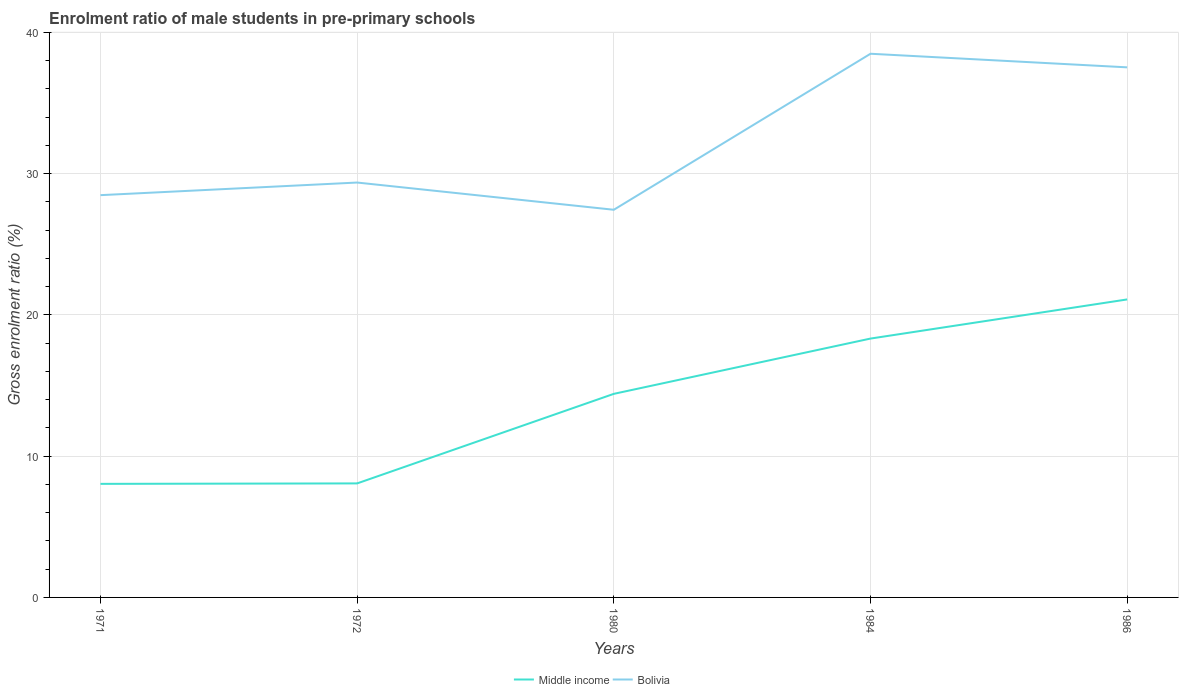Does the line corresponding to Bolivia intersect with the line corresponding to Middle income?
Give a very brief answer. No. Across all years, what is the maximum enrolment ratio of male students in pre-primary schools in Bolivia?
Your answer should be very brief. 27.44. In which year was the enrolment ratio of male students in pre-primary schools in Bolivia maximum?
Ensure brevity in your answer.  1980. What is the total enrolment ratio of male students in pre-primary schools in Bolivia in the graph?
Your response must be concise. -10.01. What is the difference between the highest and the second highest enrolment ratio of male students in pre-primary schools in Middle income?
Offer a terse response. 13.05. What is the difference between the highest and the lowest enrolment ratio of male students in pre-primary schools in Bolivia?
Provide a short and direct response. 2. How many lines are there?
Provide a succinct answer. 2. How many legend labels are there?
Your answer should be compact. 2. How are the legend labels stacked?
Give a very brief answer. Horizontal. What is the title of the graph?
Offer a very short reply. Enrolment ratio of male students in pre-primary schools. What is the label or title of the X-axis?
Offer a very short reply. Years. What is the Gross enrolment ratio (%) of Middle income in 1971?
Make the answer very short. 8.04. What is the Gross enrolment ratio (%) of Bolivia in 1971?
Your answer should be very brief. 28.47. What is the Gross enrolment ratio (%) of Middle income in 1972?
Offer a terse response. 8.07. What is the Gross enrolment ratio (%) of Bolivia in 1972?
Your response must be concise. 29.36. What is the Gross enrolment ratio (%) of Middle income in 1980?
Your answer should be compact. 14.41. What is the Gross enrolment ratio (%) in Bolivia in 1980?
Offer a terse response. 27.44. What is the Gross enrolment ratio (%) in Middle income in 1984?
Provide a succinct answer. 18.32. What is the Gross enrolment ratio (%) in Bolivia in 1984?
Provide a short and direct response. 38.48. What is the Gross enrolment ratio (%) of Middle income in 1986?
Give a very brief answer. 21.09. What is the Gross enrolment ratio (%) of Bolivia in 1986?
Your answer should be compact. 37.52. Across all years, what is the maximum Gross enrolment ratio (%) in Middle income?
Your answer should be compact. 21.09. Across all years, what is the maximum Gross enrolment ratio (%) in Bolivia?
Your answer should be compact. 38.48. Across all years, what is the minimum Gross enrolment ratio (%) of Middle income?
Provide a short and direct response. 8.04. Across all years, what is the minimum Gross enrolment ratio (%) in Bolivia?
Offer a very short reply. 27.44. What is the total Gross enrolment ratio (%) in Middle income in the graph?
Your answer should be compact. 69.93. What is the total Gross enrolment ratio (%) in Bolivia in the graph?
Give a very brief answer. 161.27. What is the difference between the Gross enrolment ratio (%) in Middle income in 1971 and that in 1972?
Ensure brevity in your answer.  -0.03. What is the difference between the Gross enrolment ratio (%) in Bolivia in 1971 and that in 1972?
Give a very brief answer. -0.89. What is the difference between the Gross enrolment ratio (%) in Middle income in 1971 and that in 1980?
Make the answer very short. -6.37. What is the difference between the Gross enrolment ratio (%) in Bolivia in 1971 and that in 1980?
Your response must be concise. 1.03. What is the difference between the Gross enrolment ratio (%) in Middle income in 1971 and that in 1984?
Provide a short and direct response. -10.28. What is the difference between the Gross enrolment ratio (%) in Bolivia in 1971 and that in 1984?
Offer a very short reply. -10.01. What is the difference between the Gross enrolment ratio (%) of Middle income in 1971 and that in 1986?
Your answer should be very brief. -13.05. What is the difference between the Gross enrolment ratio (%) in Bolivia in 1971 and that in 1986?
Give a very brief answer. -9.05. What is the difference between the Gross enrolment ratio (%) of Middle income in 1972 and that in 1980?
Your answer should be compact. -6.34. What is the difference between the Gross enrolment ratio (%) of Bolivia in 1972 and that in 1980?
Provide a short and direct response. 1.93. What is the difference between the Gross enrolment ratio (%) in Middle income in 1972 and that in 1984?
Provide a succinct answer. -10.25. What is the difference between the Gross enrolment ratio (%) of Bolivia in 1972 and that in 1984?
Your answer should be compact. -9.11. What is the difference between the Gross enrolment ratio (%) in Middle income in 1972 and that in 1986?
Provide a succinct answer. -13.02. What is the difference between the Gross enrolment ratio (%) in Bolivia in 1972 and that in 1986?
Make the answer very short. -8.15. What is the difference between the Gross enrolment ratio (%) in Middle income in 1980 and that in 1984?
Offer a very short reply. -3.91. What is the difference between the Gross enrolment ratio (%) of Bolivia in 1980 and that in 1984?
Offer a very short reply. -11.04. What is the difference between the Gross enrolment ratio (%) in Middle income in 1980 and that in 1986?
Give a very brief answer. -6.68. What is the difference between the Gross enrolment ratio (%) in Bolivia in 1980 and that in 1986?
Make the answer very short. -10.08. What is the difference between the Gross enrolment ratio (%) in Middle income in 1984 and that in 1986?
Ensure brevity in your answer.  -2.77. What is the difference between the Gross enrolment ratio (%) in Bolivia in 1984 and that in 1986?
Offer a very short reply. 0.96. What is the difference between the Gross enrolment ratio (%) of Middle income in 1971 and the Gross enrolment ratio (%) of Bolivia in 1972?
Offer a very short reply. -21.33. What is the difference between the Gross enrolment ratio (%) of Middle income in 1971 and the Gross enrolment ratio (%) of Bolivia in 1980?
Offer a terse response. -19.4. What is the difference between the Gross enrolment ratio (%) of Middle income in 1971 and the Gross enrolment ratio (%) of Bolivia in 1984?
Ensure brevity in your answer.  -30.44. What is the difference between the Gross enrolment ratio (%) in Middle income in 1971 and the Gross enrolment ratio (%) in Bolivia in 1986?
Make the answer very short. -29.48. What is the difference between the Gross enrolment ratio (%) of Middle income in 1972 and the Gross enrolment ratio (%) of Bolivia in 1980?
Ensure brevity in your answer.  -19.37. What is the difference between the Gross enrolment ratio (%) in Middle income in 1972 and the Gross enrolment ratio (%) in Bolivia in 1984?
Provide a short and direct response. -30.41. What is the difference between the Gross enrolment ratio (%) of Middle income in 1972 and the Gross enrolment ratio (%) of Bolivia in 1986?
Make the answer very short. -29.45. What is the difference between the Gross enrolment ratio (%) in Middle income in 1980 and the Gross enrolment ratio (%) in Bolivia in 1984?
Provide a short and direct response. -24.07. What is the difference between the Gross enrolment ratio (%) in Middle income in 1980 and the Gross enrolment ratio (%) in Bolivia in 1986?
Your answer should be very brief. -23.11. What is the difference between the Gross enrolment ratio (%) in Middle income in 1984 and the Gross enrolment ratio (%) in Bolivia in 1986?
Provide a succinct answer. -19.2. What is the average Gross enrolment ratio (%) of Middle income per year?
Your response must be concise. 13.99. What is the average Gross enrolment ratio (%) of Bolivia per year?
Your answer should be very brief. 32.25. In the year 1971, what is the difference between the Gross enrolment ratio (%) in Middle income and Gross enrolment ratio (%) in Bolivia?
Provide a short and direct response. -20.43. In the year 1972, what is the difference between the Gross enrolment ratio (%) in Middle income and Gross enrolment ratio (%) in Bolivia?
Your answer should be compact. -21.29. In the year 1980, what is the difference between the Gross enrolment ratio (%) in Middle income and Gross enrolment ratio (%) in Bolivia?
Provide a short and direct response. -13.03. In the year 1984, what is the difference between the Gross enrolment ratio (%) in Middle income and Gross enrolment ratio (%) in Bolivia?
Offer a terse response. -20.16. In the year 1986, what is the difference between the Gross enrolment ratio (%) in Middle income and Gross enrolment ratio (%) in Bolivia?
Your response must be concise. -16.43. What is the ratio of the Gross enrolment ratio (%) of Bolivia in 1971 to that in 1972?
Provide a succinct answer. 0.97. What is the ratio of the Gross enrolment ratio (%) of Middle income in 1971 to that in 1980?
Your answer should be compact. 0.56. What is the ratio of the Gross enrolment ratio (%) in Bolivia in 1971 to that in 1980?
Keep it short and to the point. 1.04. What is the ratio of the Gross enrolment ratio (%) in Middle income in 1971 to that in 1984?
Provide a succinct answer. 0.44. What is the ratio of the Gross enrolment ratio (%) in Bolivia in 1971 to that in 1984?
Provide a succinct answer. 0.74. What is the ratio of the Gross enrolment ratio (%) in Middle income in 1971 to that in 1986?
Offer a very short reply. 0.38. What is the ratio of the Gross enrolment ratio (%) in Bolivia in 1971 to that in 1986?
Make the answer very short. 0.76. What is the ratio of the Gross enrolment ratio (%) in Middle income in 1972 to that in 1980?
Offer a very short reply. 0.56. What is the ratio of the Gross enrolment ratio (%) of Bolivia in 1972 to that in 1980?
Give a very brief answer. 1.07. What is the ratio of the Gross enrolment ratio (%) of Middle income in 1972 to that in 1984?
Your answer should be very brief. 0.44. What is the ratio of the Gross enrolment ratio (%) of Bolivia in 1972 to that in 1984?
Ensure brevity in your answer.  0.76. What is the ratio of the Gross enrolment ratio (%) in Middle income in 1972 to that in 1986?
Provide a short and direct response. 0.38. What is the ratio of the Gross enrolment ratio (%) in Bolivia in 1972 to that in 1986?
Make the answer very short. 0.78. What is the ratio of the Gross enrolment ratio (%) in Middle income in 1980 to that in 1984?
Offer a terse response. 0.79. What is the ratio of the Gross enrolment ratio (%) in Bolivia in 1980 to that in 1984?
Ensure brevity in your answer.  0.71. What is the ratio of the Gross enrolment ratio (%) of Middle income in 1980 to that in 1986?
Give a very brief answer. 0.68. What is the ratio of the Gross enrolment ratio (%) of Bolivia in 1980 to that in 1986?
Offer a very short reply. 0.73. What is the ratio of the Gross enrolment ratio (%) of Middle income in 1984 to that in 1986?
Your answer should be very brief. 0.87. What is the ratio of the Gross enrolment ratio (%) of Bolivia in 1984 to that in 1986?
Ensure brevity in your answer.  1.03. What is the difference between the highest and the second highest Gross enrolment ratio (%) of Middle income?
Keep it short and to the point. 2.77. What is the difference between the highest and the second highest Gross enrolment ratio (%) of Bolivia?
Your response must be concise. 0.96. What is the difference between the highest and the lowest Gross enrolment ratio (%) of Middle income?
Make the answer very short. 13.05. What is the difference between the highest and the lowest Gross enrolment ratio (%) in Bolivia?
Your response must be concise. 11.04. 